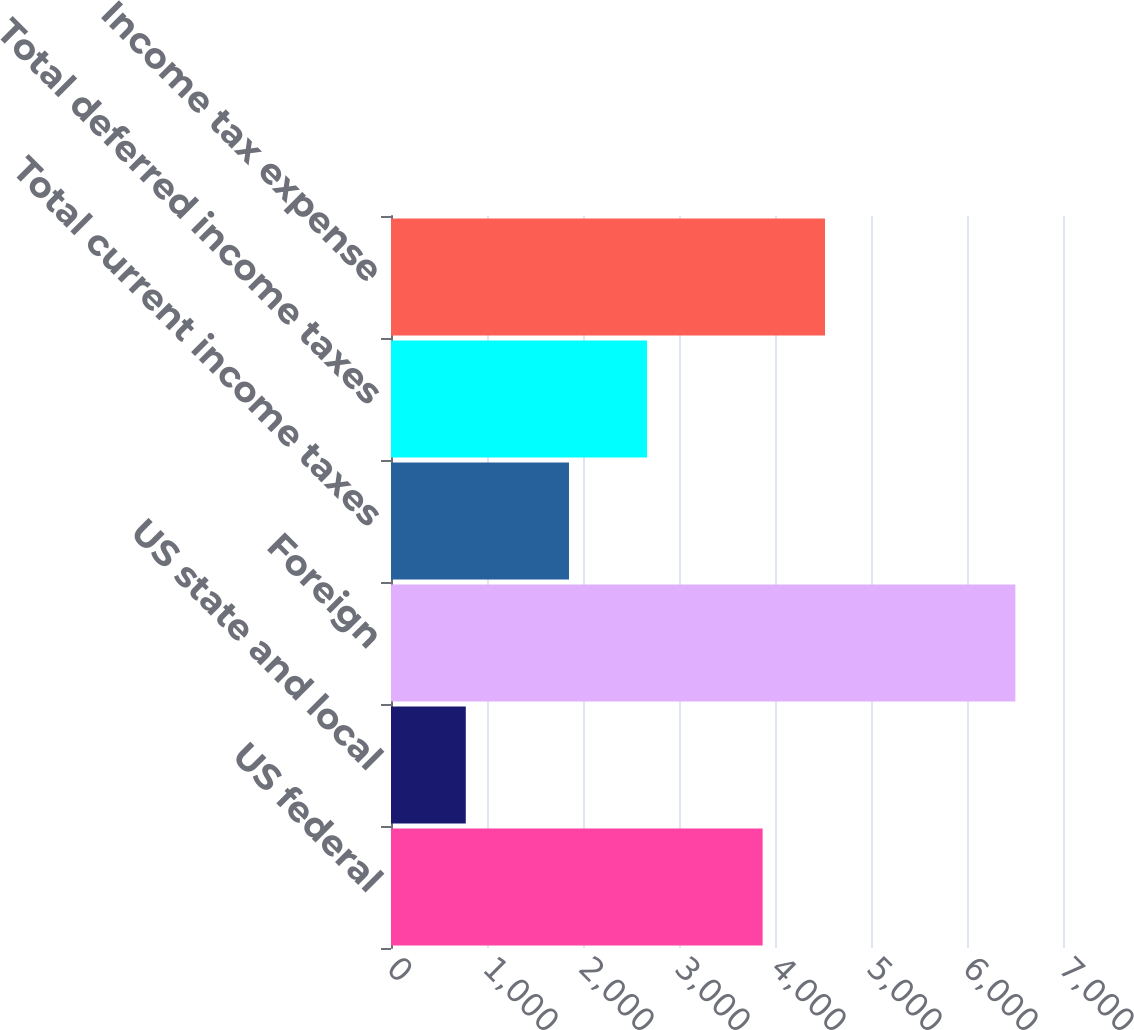<chart> <loc_0><loc_0><loc_500><loc_500><bar_chart><fcel>US federal<fcel>US state and local<fcel>Foreign<fcel>Total current income taxes<fcel>Total deferred income taxes<fcel>Income tax expense<nl><fcel>3871<fcel>779<fcel>6504<fcel>1854<fcel>2667<fcel>4521<nl></chart> 